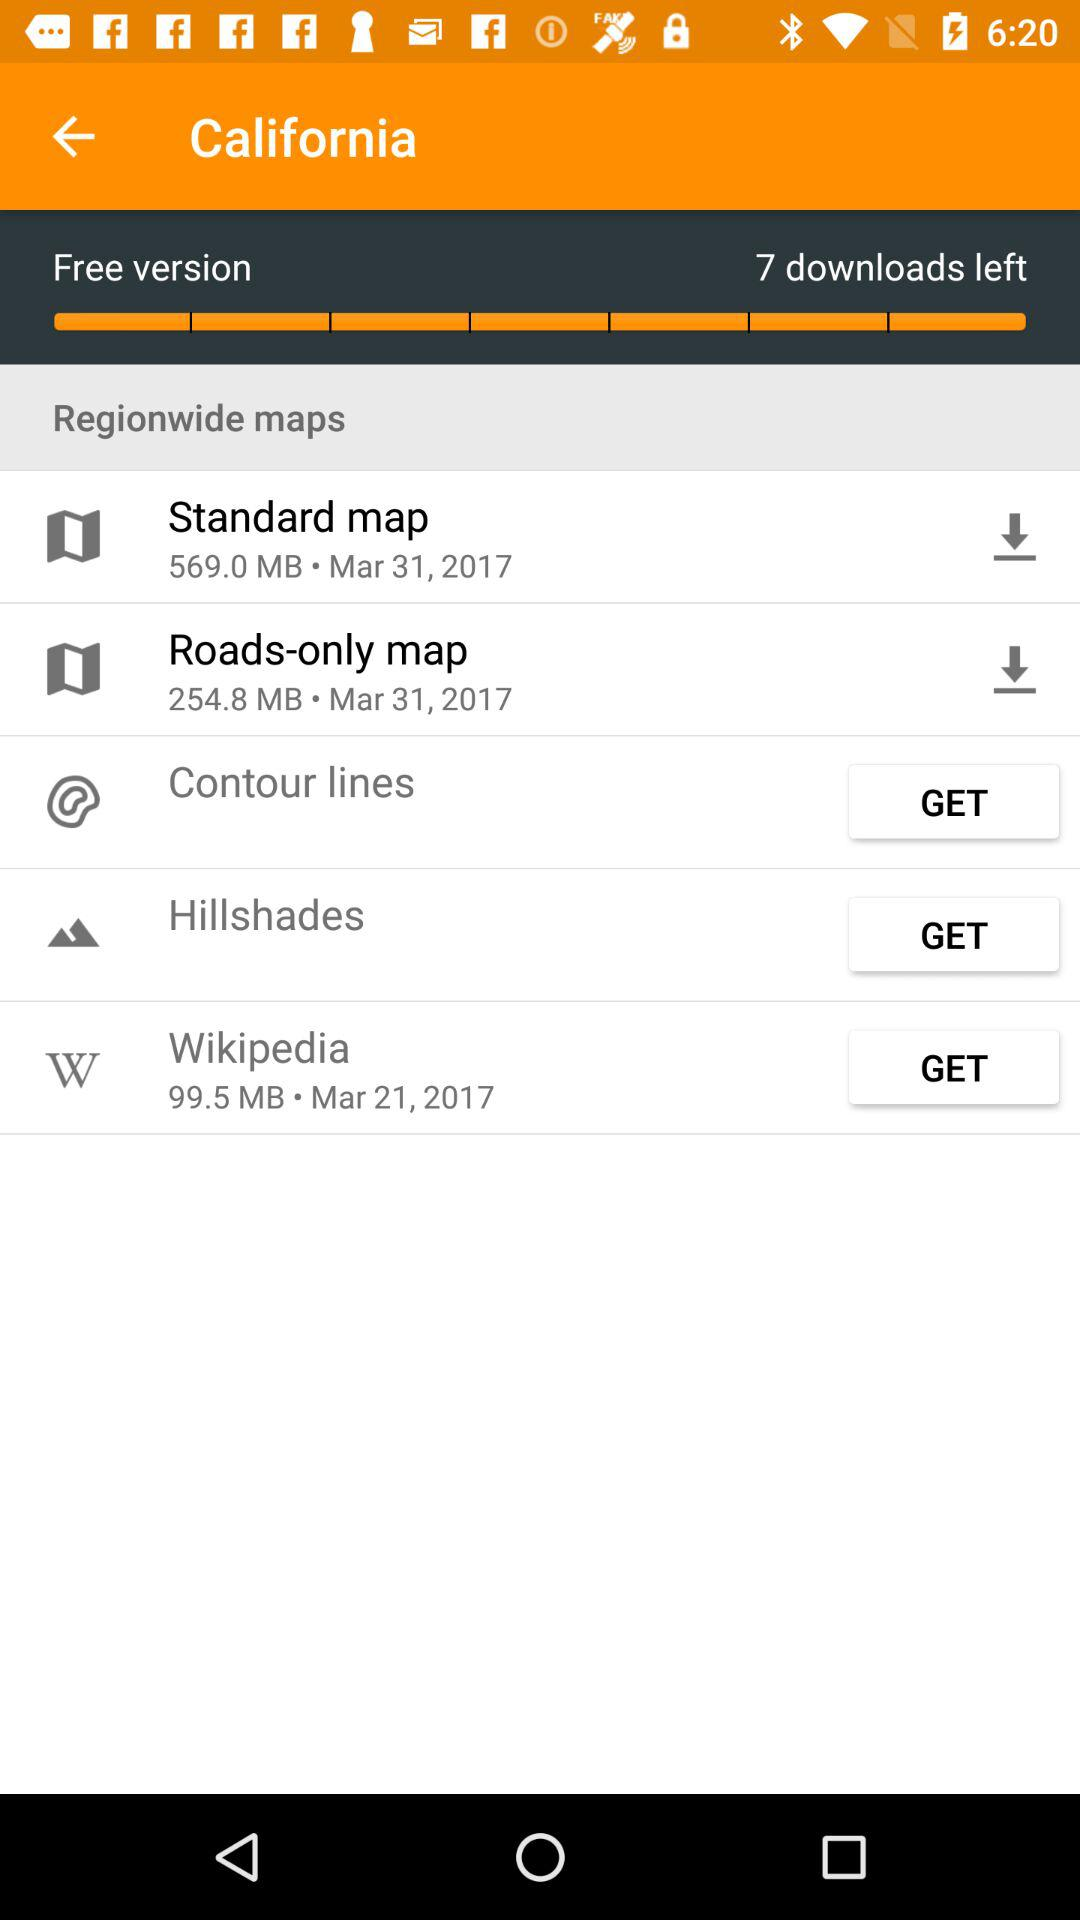What is the size of "Wikipedia"? The size of "Wikipedia" is 99.5 MB. 